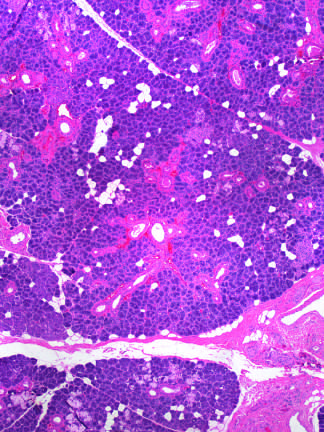what is vascular changes and fibrosis of salivary glands produced by?
Answer the question using a single word or phrase. Radiation therapy of the neck region 